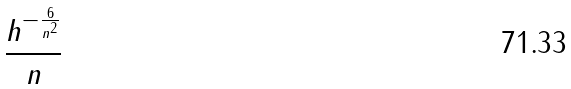Convert formula to latex. <formula><loc_0><loc_0><loc_500><loc_500>\frac { h ^ { - \frac { 6 } { n ^ { 2 } } } } { n }</formula> 